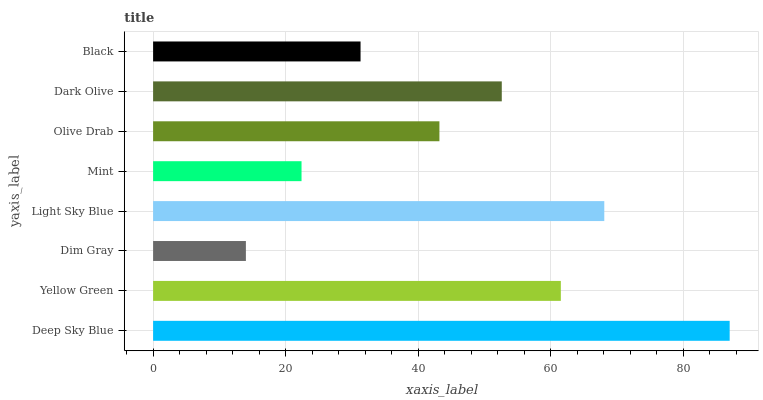Is Dim Gray the minimum?
Answer yes or no. Yes. Is Deep Sky Blue the maximum?
Answer yes or no. Yes. Is Yellow Green the minimum?
Answer yes or no. No. Is Yellow Green the maximum?
Answer yes or no. No. Is Deep Sky Blue greater than Yellow Green?
Answer yes or no. Yes. Is Yellow Green less than Deep Sky Blue?
Answer yes or no. Yes. Is Yellow Green greater than Deep Sky Blue?
Answer yes or no. No. Is Deep Sky Blue less than Yellow Green?
Answer yes or no. No. Is Dark Olive the high median?
Answer yes or no. Yes. Is Olive Drab the low median?
Answer yes or no. Yes. Is Black the high median?
Answer yes or no. No. Is Black the low median?
Answer yes or no. No. 